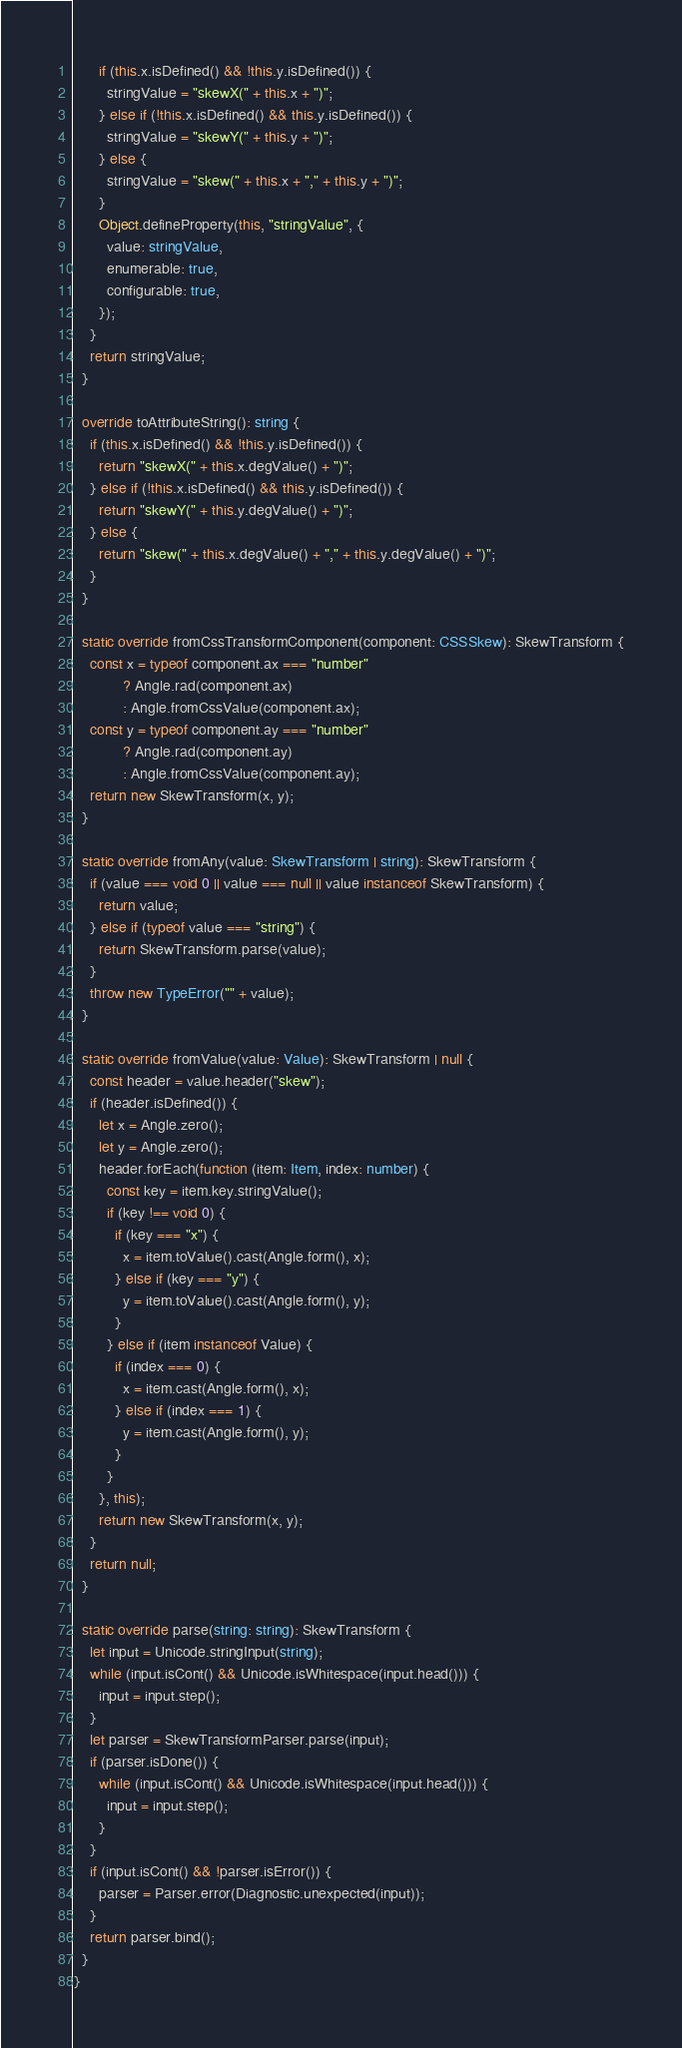Convert code to text. <code><loc_0><loc_0><loc_500><loc_500><_TypeScript_>      if (this.x.isDefined() && !this.y.isDefined()) {
        stringValue = "skewX(" + this.x + ")";
      } else if (!this.x.isDefined() && this.y.isDefined()) {
        stringValue = "skewY(" + this.y + ")";
      } else {
        stringValue = "skew(" + this.x + "," + this.y + ")";
      }
      Object.defineProperty(this, "stringValue", {
        value: stringValue,
        enumerable: true,
        configurable: true,
      });
    }
    return stringValue;
  }

  override toAttributeString(): string {
    if (this.x.isDefined() && !this.y.isDefined()) {
      return "skewX(" + this.x.degValue() + ")";
    } else if (!this.x.isDefined() && this.y.isDefined()) {
      return "skewY(" + this.y.degValue() + ")";
    } else {
      return "skew(" + this.x.degValue() + "," + this.y.degValue() + ")";
    }
  }

  static override fromCssTransformComponent(component: CSSSkew): SkewTransform {
    const x = typeof component.ax === "number"
            ? Angle.rad(component.ax)
            : Angle.fromCssValue(component.ax);
    const y = typeof component.ay === "number"
            ? Angle.rad(component.ay)
            : Angle.fromCssValue(component.ay);
    return new SkewTransform(x, y);
  }

  static override fromAny(value: SkewTransform | string): SkewTransform {
    if (value === void 0 || value === null || value instanceof SkewTransform) {
      return value;
    } else if (typeof value === "string") {
      return SkewTransform.parse(value);
    }
    throw new TypeError("" + value);
  }

  static override fromValue(value: Value): SkewTransform | null {
    const header = value.header("skew");
    if (header.isDefined()) {
      let x = Angle.zero();
      let y = Angle.zero();
      header.forEach(function (item: Item, index: number) {
        const key = item.key.stringValue();
        if (key !== void 0) {
          if (key === "x") {
            x = item.toValue().cast(Angle.form(), x);
          } else if (key === "y") {
            y = item.toValue().cast(Angle.form(), y);
          }
        } else if (item instanceof Value) {
          if (index === 0) {
            x = item.cast(Angle.form(), x);
          } else if (index === 1) {
            y = item.cast(Angle.form(), y);
          }
        }
      }, this);
      return new SkewTransform(x, y);
    }
    return null;
  }

  static override parse(string: string): SkewTransform {
    let input = Unicode.stringInput(string);
    while (input.isCont() && Unicode.isWhitespace(input.head())) {
      input = input.step();
    }
    let parser = SkewTransformParser.parse(input);
    if (parser.isDone()) {
      while (input.isCont() && Unicode.isWhitespace(input.head())) {
        input = input.step();
      }
    }
    if (input.isCont() && !parser.isError()) {
      parser = Parser.error(Diagnostic.unexpected(input));
    }
    return parser.bind();
  }
}
</code> 